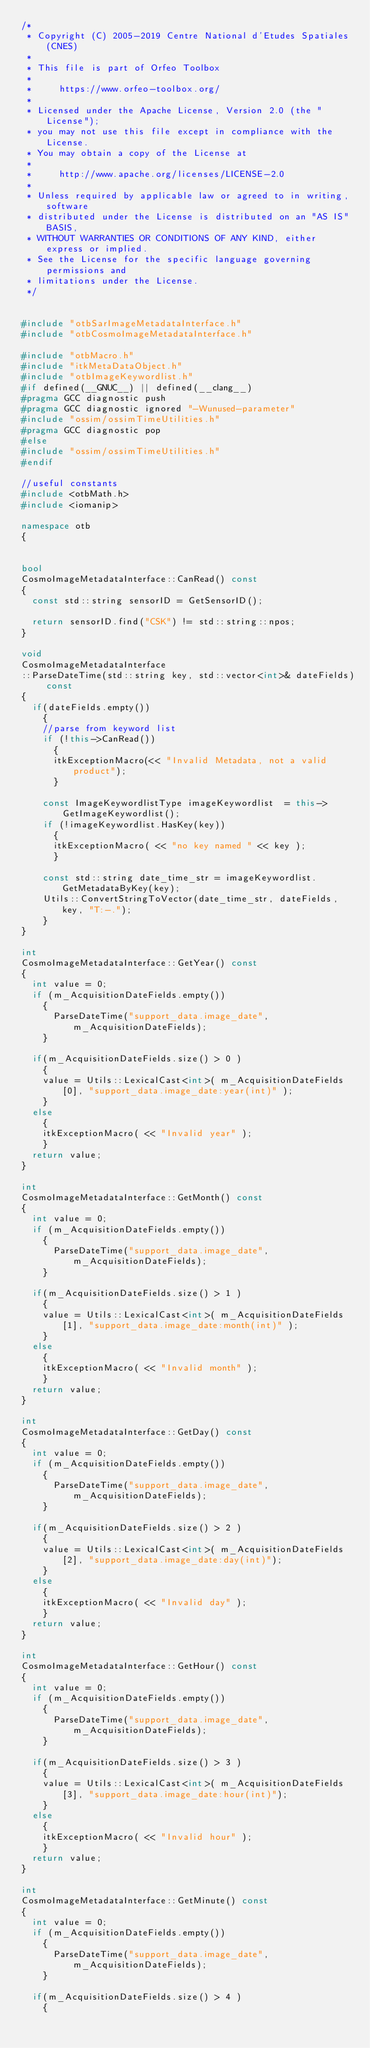Convert code to text. <code><loc_0><loc_0><loc_500><loc_500><_C++_>/*
 * Copyright (C) 2005-2019 Centre National d'Etudes Spatiales (CNES)
 *
 * This file is part of Orfeo Toolbox
 *
 *     https://www.orfeo-toolbox.org/
 *
 * Licensed under the Apache License, Version 2.0 (the "License");
 * you may not use this file except in compliance with the License.
 * You may obtain a copy of the License at
 *
 *     http://www.apache.org/licenses/LICENSE-2.0
 *
 * Unless required by applicable law or agreed to in writing, software
 * distributed under the License is distributed on an "AS IS" BASIS,
 * WITHOUT WARRANTIES OR CONDITIONS OF ANY KIND, either express or implied.
 * See the License for the specific language governing permissions and
 * limitations under the License.
 */


#include "otbSarImageMetadataInterface.h"
#include "otbCosmoImageMetadataInterface.h"

#include "otbMacro.h"
#include "itkMetaDataObject.h"
#include "otbImageKeywordlist.h"
#if defined(__GNUC__) || defined(__clang__)
#pragma GCC diagnostic push
#pragma GCC diagnostic ignored "-Wunused-parameter"
#include "ossim/ossimTimeUtilities.h"
#pragma GCC diagnostic pop
#else
#include "ossim/ossimTimeUtilities.h"
#endif

//useful constants
#include <otbMath.h>
#include <iomanip>

namespace otb
{


bool
CosmoImageMetadataInterface::CanRead() const
{
  const std::string sensorID = GetSensorID();  

  return sensorID.find("CSK") != std::string::npos;
}

void
CosmoImageMetadataInterface
::ParseDateTime(std::string key, std::vector<int>& dateFields) const
{
  if(dateFields.empty())
    {
    //parse from keyword list
    if (!this->CanRead())
      {
      itkExceptionMacro(<< "Invalid Metadata, not a valid product");
      }

    const ImageKeywordlistType imageKeywordlist  = this->GetImageKeywordlist();
    if (!imageKeywordlist.HasKey(key))
      {
      itkExceptionMacro( << "no key named " << key );
      }

    const std::string date_time_str = imageKeywordlist.GetMetadataByKey(key);
    Utils::ConvertStringToVector(date_time_str, dateFields, key, "T:-.");
    }
}

int
CosmoImageMetadataInterface::GetYear() const
{
  int value = 0;
  if (m_AcquisitionDateFields.empty())
    {
      ParseDateTime("support_data.image_date", m_AcquisitionDateFields);
    }
      
  if(m_AcquisitionDateFields.size() > 0 )
    {
    value = Utils::LexicalCast<int>( m_AcquisitionDateFields[0], "support_data.image_date:year(int)" );
    }
  else
    {
    itkExceptionMacro( << "Invalid year" );
    }
  return value;
}

int
CosmoImageMetadataInterface::GetMonth() const
{
  int value = 0;
  if (m_AcquisitionDateFields.empty())
    {
      ParseDateTime("support_data.image_date", m_AcquisitionDateFields);
    }

  if(m_AcquisitionDateFields.size() > 1 )
    {
    value = Utils::LexicalCast<int>( m_AcquisitionDateFields[1], "support_data.image_date:month(int)" );
    }
  else
    {
    itkExceptionMacro( << "Invalid month" );
    }
  return value;
}

int
CosmoImageMetadataInterface::GetDay() const
{
  int value = 0;
  if (m_AcquisitionDateFields.empty())
    {
      ParseDateTime("support_data.image_date", m_AcquisitionDateFields);
    }

  if(m_AcquisitionDateFields.size() > 2 )
    {
    value = Utils::LexicalCast<int>( m_AcquisitionDateFields[2], "support_data.image_date:day(int)");
    }
  else
    {
    itkExceptionMacro( << "Invalid day" );
    }
  return value;
}

int
CosmoImageMetadataInterface::GetHour() const
{
  int value = 0;
  if (m_AcquisitionDateFields.empty())
    {
      ParseDateTime("support_data.image_date", m_AcquisitionDateFields);
    }

  if(m_AcquisitionDateFields.size() > 3 )
    {
    value = Utils::LexicalCast<int>( m_AcquisitionDateFields[3], "support_data.image_date:hour(int)");
    }
  else
    {
    itkExceptionMacro( << "Invalid hour" );
    }
  return value;
}

int
CosmoImageMetadataInterface::GetMinute() const
{
  int value = 0;
  if (m_AcquisitionDateFields.empty())
    {
      ParseDateTime("support_data.image_date", m_AcquisitionDateFields);
    }
  
  if(m_AcquisitionDateFields.size() > 4 )
    {</code> 